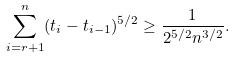Convert formula to latex. <formula><loc_0><loc_0><loc_500><loc_500>\sum _ { i = r + 1 } ^ { n } ( t _ { i } - t _ { i - 1 } ) ^ { 5 / 2 } \geq \frac { 1 } { 2 ^ { 5 / 2 } n ^ { 3 / 2 } } .</formula> 